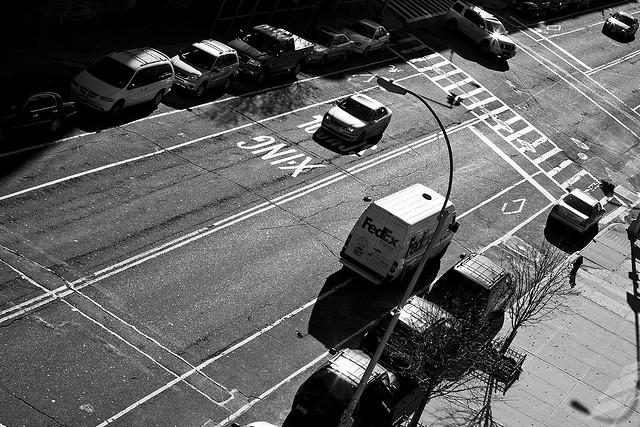Is there someone on the sidewalk?
Write a very short answer. Yes. Are the trees naked of leaves?
Be succinct. Yes. What do the short, close, striped markings mean?
Answer briefly. Crosswalk. 